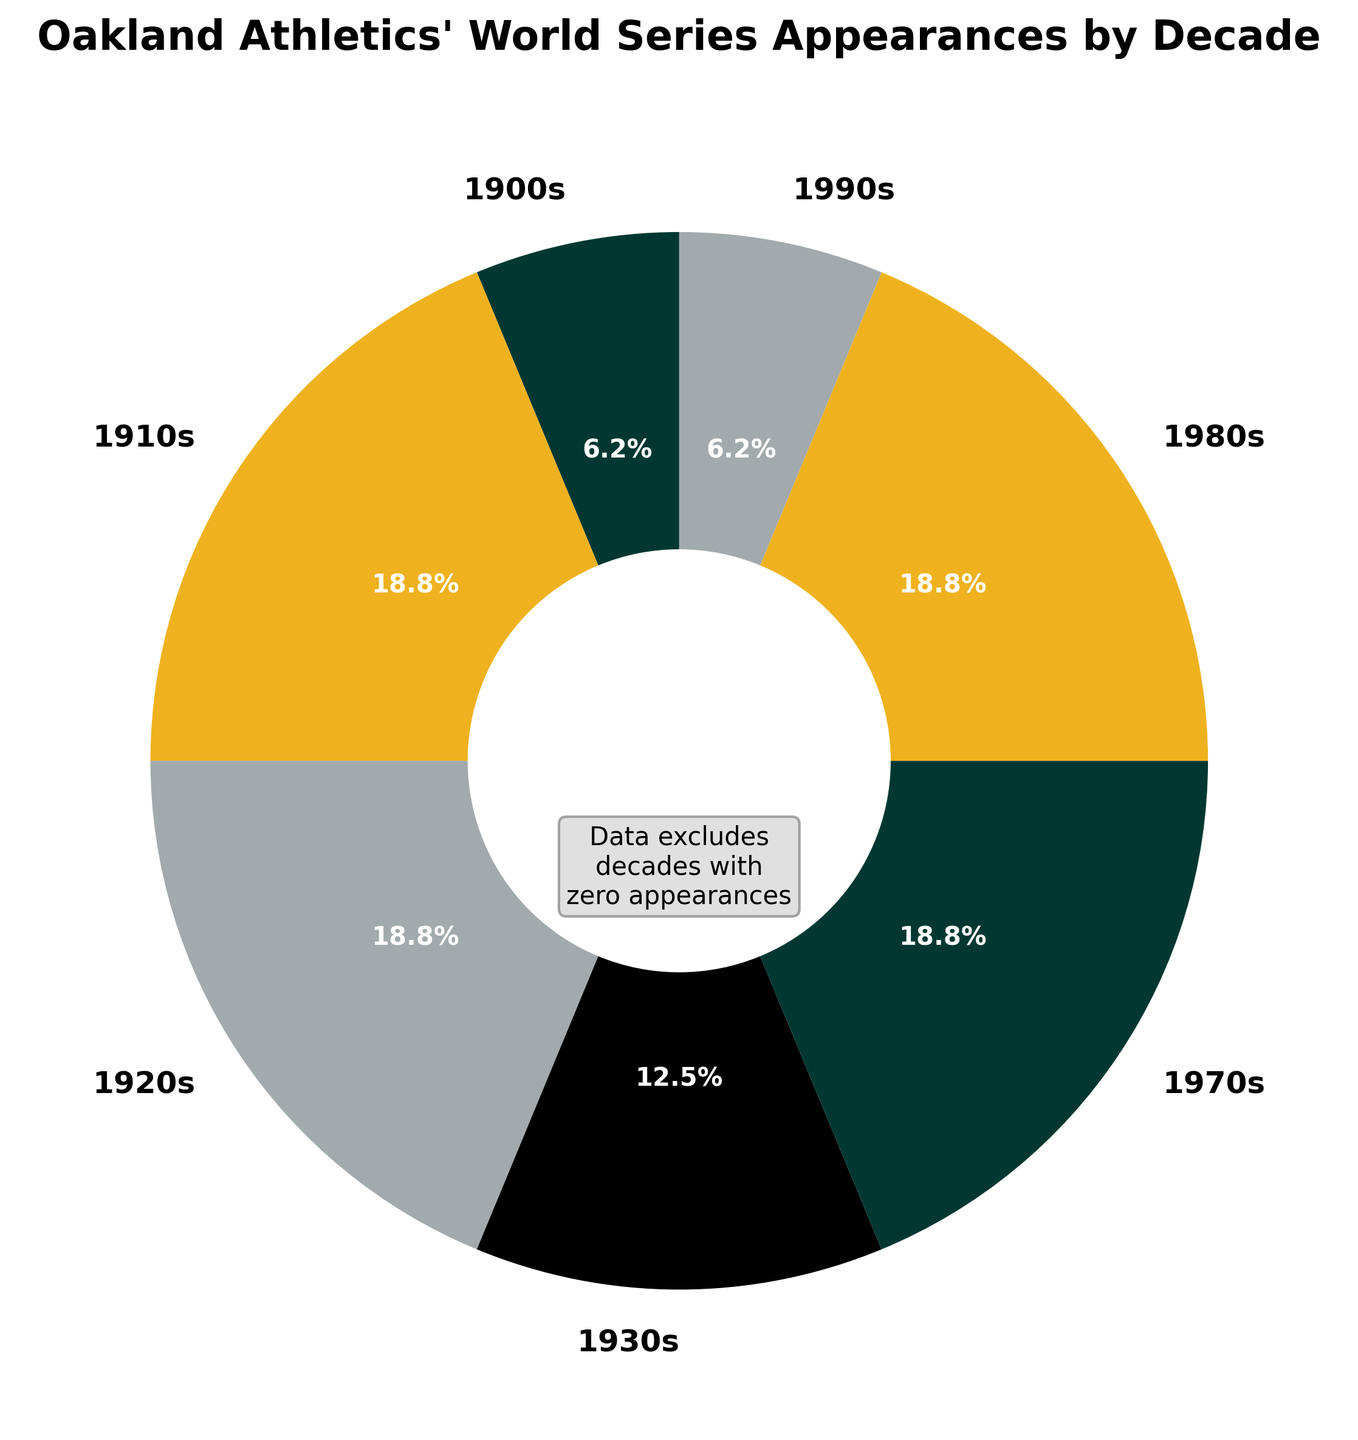Which decade had the highest number of World Series appearances? From the pie chart, observe the slices for each decade. The 1910s, 1920s, 1970s, and 1980s all have equivalent larger sections. Since these all have 3 appearances, these are the highest.
Answer: 1910s, 1920s, 1970s, 1980s What percentage of the Athletics’ total World Series appearances took place in the 1980s? The chart shows a slice for the 1980s labeled with a percentage. The label for the 1980s' slice shows 20.0%.
Answer: 20.0% What is the combined total percentage for the decades between 1910 and 1930? Sum the percentages for each relevant slice. The chart shows that the 1910s account for 30.0%, the 1920s account for 30.0%, and the 1930s account for 20.0%. Adding these gives 30.0% + 30.0% + 20.0% = 80.0%.
Answer: 80.0% How many decades did the Athletics have zero World Series appearances? The chart states that non-zero appearances are only shown. This means all other decades not shown must have zero appearances. Count the excluded decades: 2000s, 2010s, 2020s, and 1940s, 1950s, 1960s. 6 decades are implied zero-out, but the chart can't provide additional decades not provided in data.
Answer: 3 (from 2000s, 2010s, 2020s) Which decade had a smaller number of appearances, the 1900s or the 1990s? Look at the sizes of the slices for the 1900s and 1990s. Both have 1 appearance, but by percentage, they show smaller wisdom distribution, equal 10.0% each.
Answer: Both have 1 appearance What fraction of total World Series appearances happened before 1940? Consider the slices for corresponding decades. From the chart, those are the 1900s (1 appearance), 1910s (3 appearances), 1920s (3 appearances), and 1930s (2 appearances). Summing these: 1 + 3 + 3 + 2 = 9 appearances. Total appearances are 1 + 3 + 3 + 2 + 3 + 3 + 1 = 16. The fraction is 9/16.
Answer: 9/16 Which decade's slice is colored green in the pie chart? Refer to the visual attribute of color in the chart. A green slice represents the 1970s.
Answer: 1970s What visual feature in the chart indicates that decades with zero appearances are excluded? There is an annotation in the center of the donut chart stating "Data excludes decades with zero appearances".
Answer: Annotation in the center How many decades had at least 3 World Series appearances? From the pie chart, check the slices with values of 3 or greater. These are the 1910s, 1920s, and 1980s, and 1970s (total 4 decades).
Answer: 4 